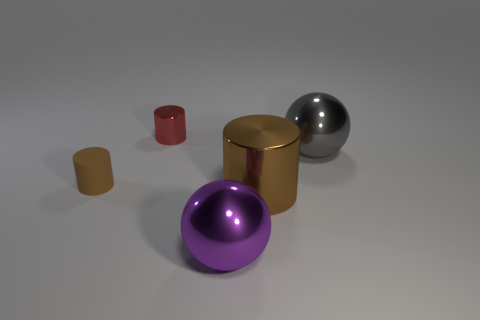Add 1 purple things. How many objects exist? 6 Subtract all balls. How many objects are left? 3 Subtract 0 yellow cylinders. How many objects are left? 5 Subtract all yellow matte blocks. Subtract all purple metallic balls. How many objects are left? 4 Add 5 small metal cylinders. How many small metal cylinders are left? 6 Add 3 purple shiny blocks. How many purple shiny blocks exist? 3 